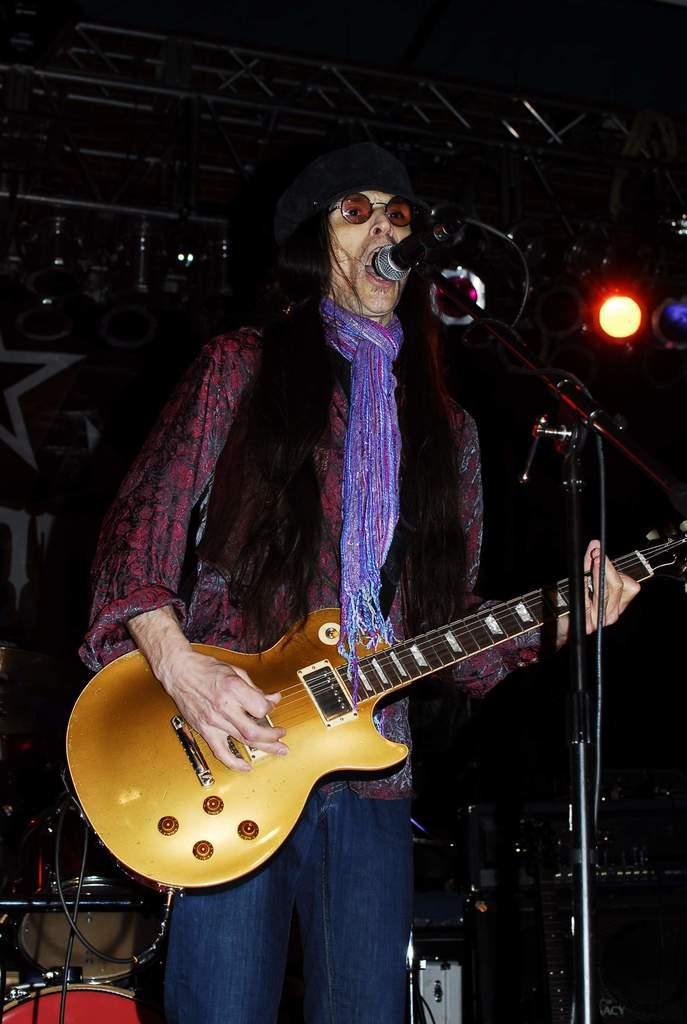In one or two sentences, can you explain what this image depicts? This image is clicked in a musical concert. There is light on the top right corner ,there is a mic in the middle, there is a person free Standing and playing guitar there are drums on the left side bottom corner. This person is wearing a scarf blue color jeans and maroon color shirt. He is also wearing specs. 